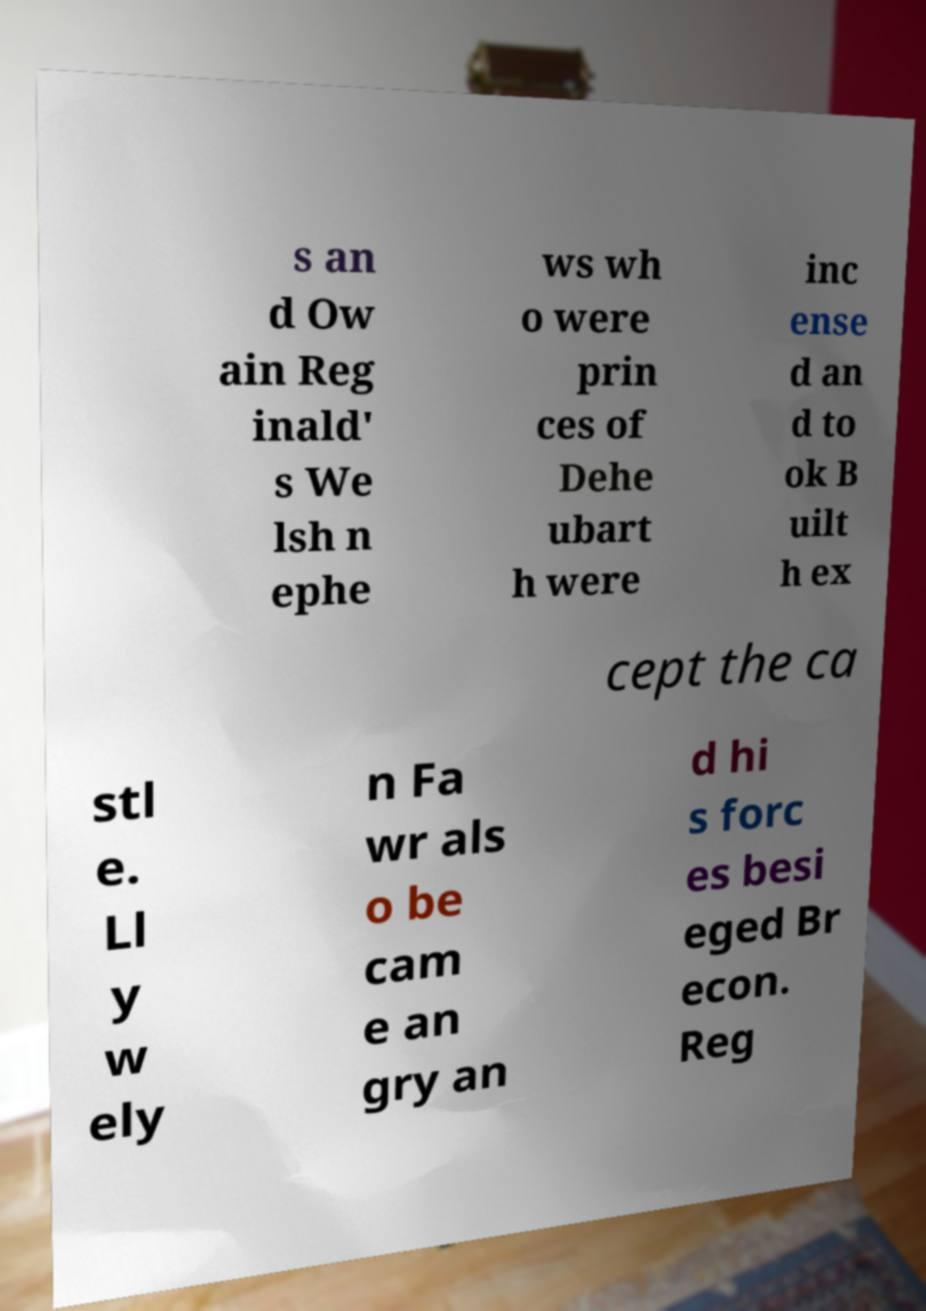Could you assist in decoding the text presented in this image and type it out clearly? s an d Ow ain Reg inald' s We lsh n ephe ws wh o were prin ces of Dehe ubart h were inc ense d an d to ok B uilt h ex cept the ca stl e. Ll y w ely n Fa wr als o be cam e an gry an d hi s forc es besi eged Br econ. Reg 